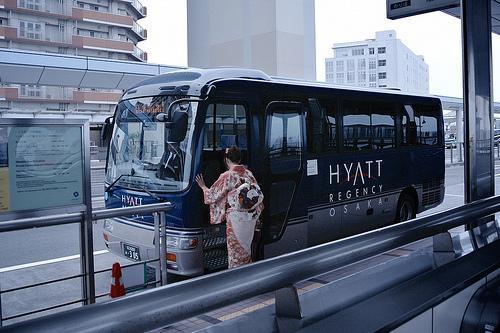How many people are there?
Give a very brief answer. 1. 